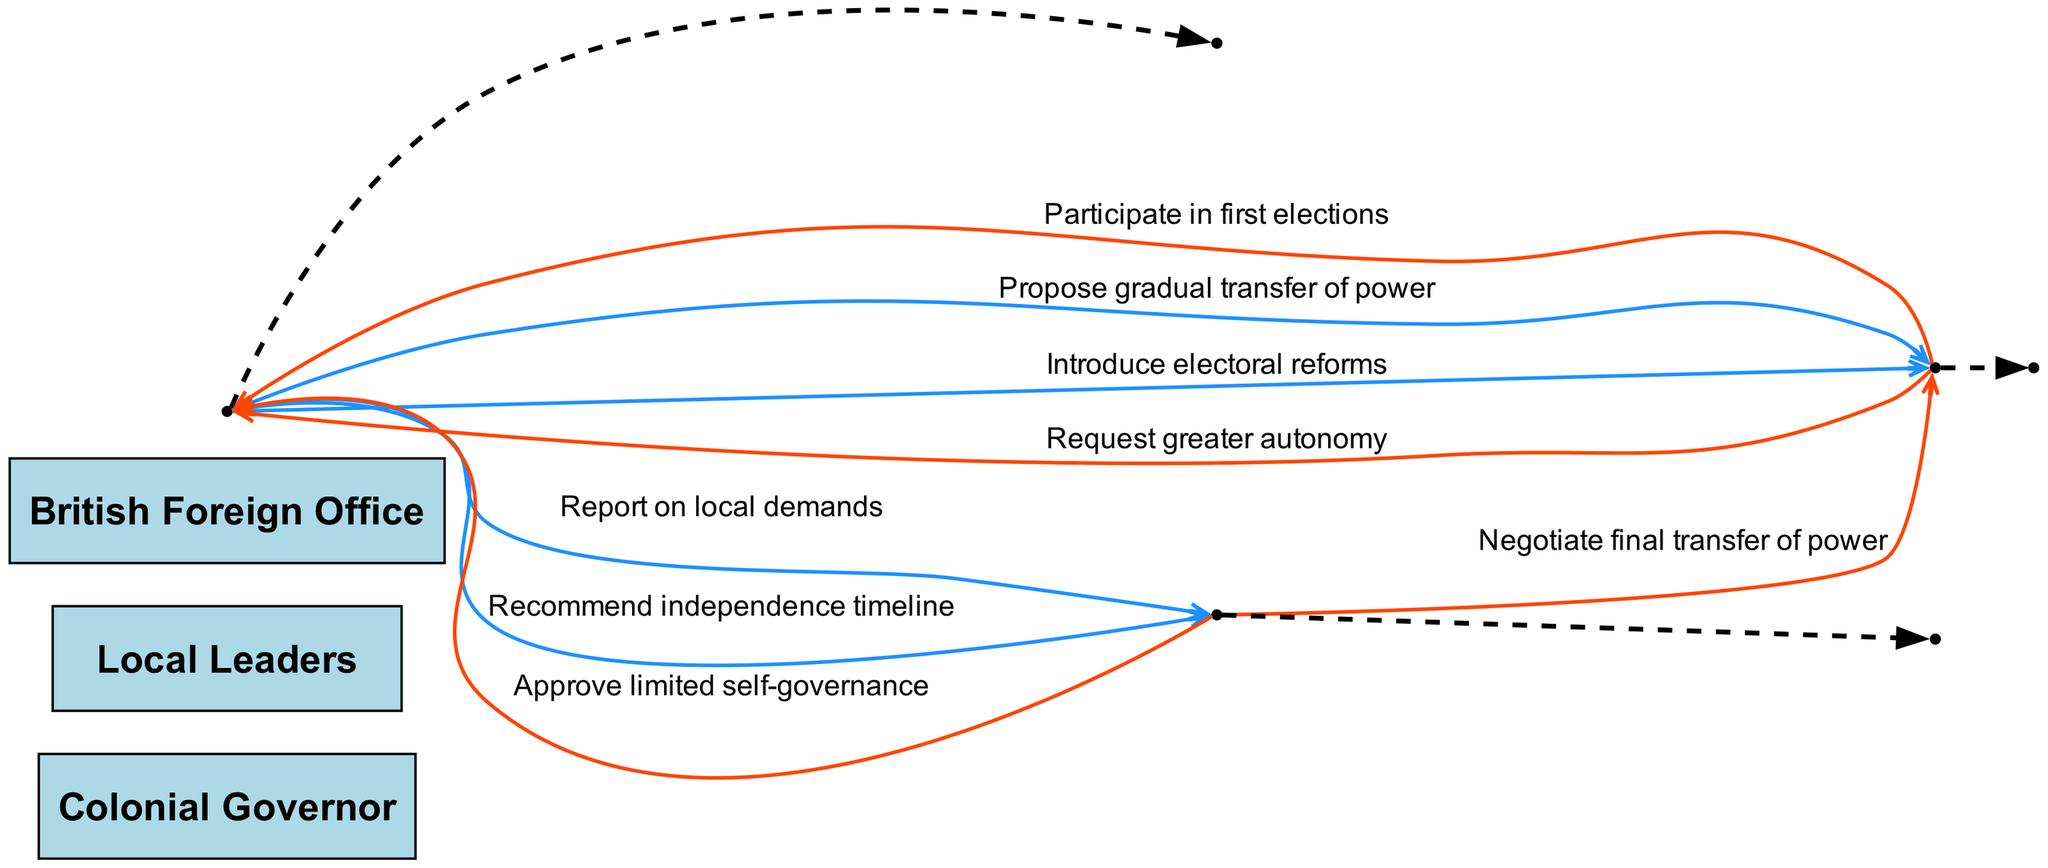What is the first interaction in the sequence? The first interaction in the sequence is between the Colonial Governor and Local Leaders, where the Colonial Governor proposes a gradual transfer of power.
Answer: Propose gradual transfer of power How many actors are present in the diagram? The diagram contains three actors: Colonial Governor, Local Leaders, and British Foreign Office.
Answer: 3 What message does the British Foreign Office send to the Colonial Governor? The British Foreign Office sends a message to the Colonial Governor to approve limited self-governance.
Answer: Approve limited self-governance What is the last interaction in the sequence? The last interaction is from the British Foreign Office to Local Leaders, negotiating the final transfer of power.
Answer: Negotiate final transfer of power Which actor initiates the introduction of electoral reforms? The Colonial Governor initiates the introduction of electoral reforms in the sequence.
Answer: Colonial Governor How many interactions are there between Local Leaders and Colonial Governor? There are four interactions between Local Leaders and the Colonial Governor throughout the sequence.
Answer: 4 What color represents the first and last edges in the diagram? The first edge is colored in blue, and the last edge is colored in red.
Answer: Blue and red What is the response action after the Colonial Governor recommends an independence timeline? The response action is a message from the British Foreign Office negotiating the final transfer of power.
Answer: Negotiate final transfer of power Which actor is responsible for reporting on local demands? The Colonial Governor is responsible for reporting on local demands to the British Foreign Office.
Answer: Colonial Governor 